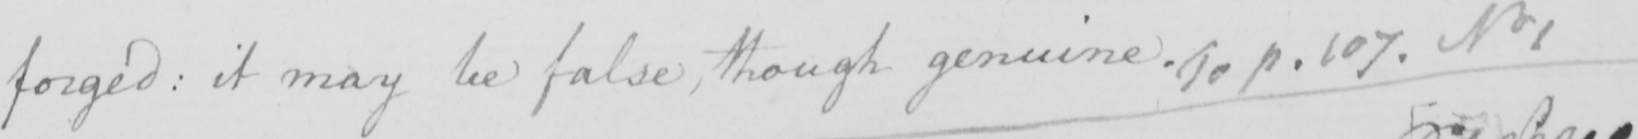Can you read and transcribe this handwriting? forged :  it may be false , though genuine . To p . 107 . No 1 